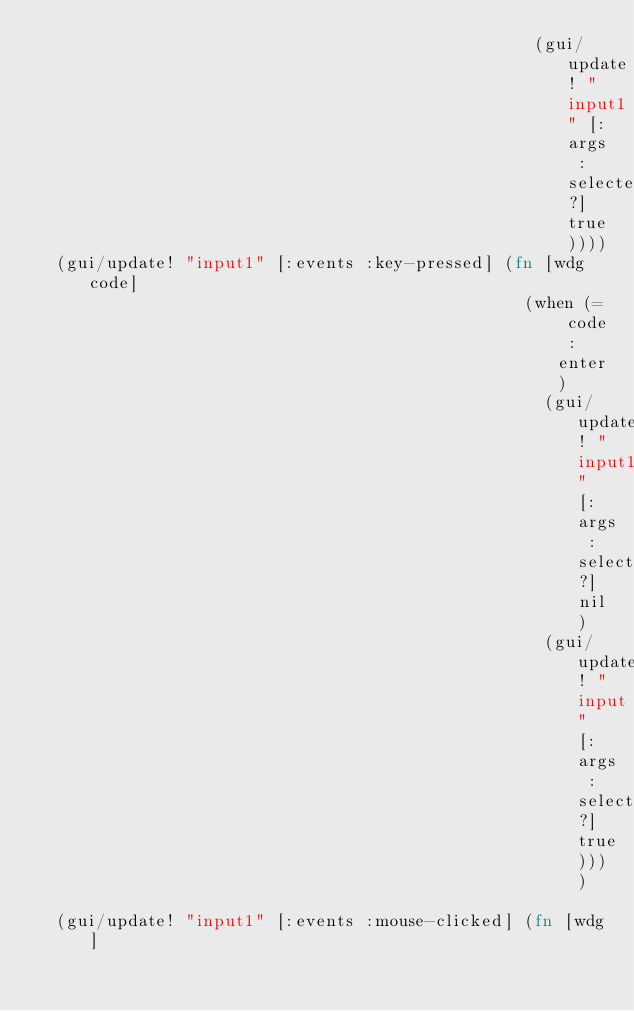Convert code to text. <code><loc_0><loc_0><loc_500><loc_500><_Clojure_>                                                  (gui/update! "input1" [:args :selected?] true))))
  (gui/update! "input1" [:events :key-pressed] (fn [wdg code]
                                                 (when (= code :enter)
                                                   (gui/update! "input1" [:args :selected?] nil)
                                                   (gui/update! "input" [:args :selected?] true))))
  
  (gui/update! "input1" [:events :mouse-clicked] (fn [wdg]</code> 